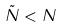<formula> <loc_0><loc_0><loc_500><loc_500>\tilde { N } < N</formula> 